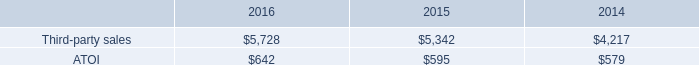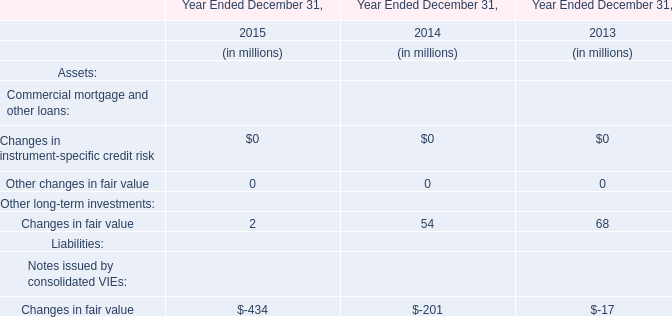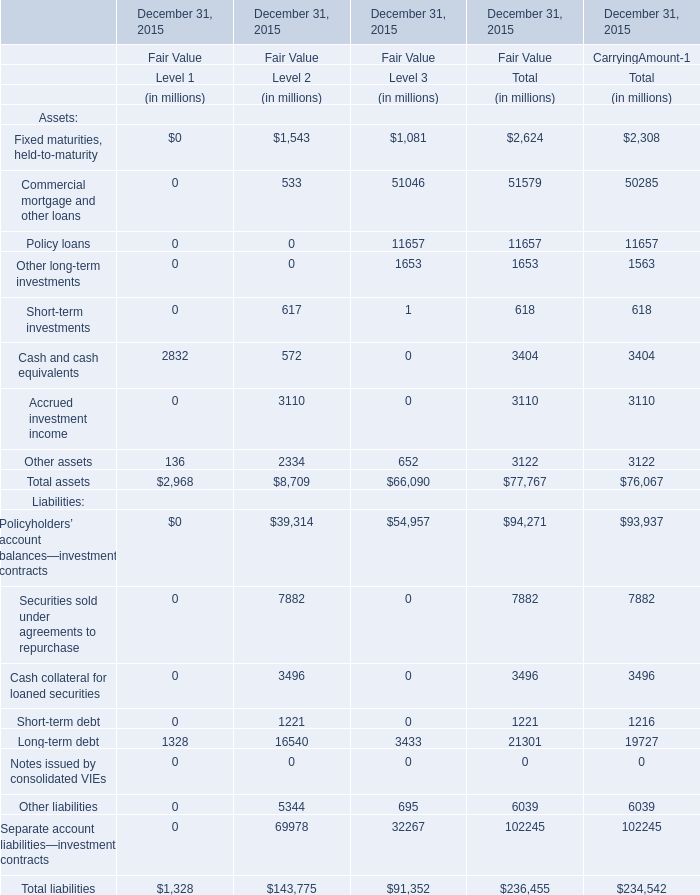What is the sum of Policy loans, Other long-term investments and Short-term investments for Fair Value of Total? (in million) 
Computations: ((11657 + 1653) + 618)
Answer: 13928.0. 